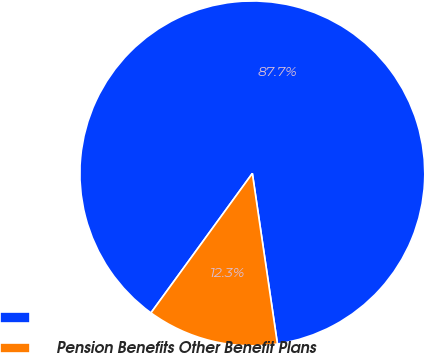Convert chart. <chart><loc_0><loc_0><loc_500><loc_500><pie_chart><ecel><fcel>Pension Benefits Other Benefit Plans<nl><fcel>87.67%<fcel>12.33%<nl></chart> 